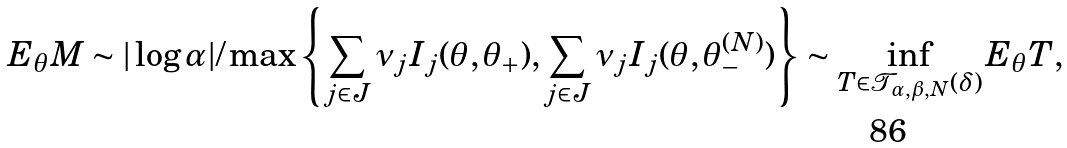<formula> <loc_0><loc_0><loc_500><loc_500>E _ { \theta } M \sim | \log \alpha | / \max \left \{ \sum _ { j \in J } \nu _ { j } I _ { j } ( \theta , \theta _ { + } ) , \sum _ { j \in J } \nu _ { j } I _ { j } ( \theta , \theta _ { - } ^ { ( N ) } ) \right \} \sim \inf _ { T \in \mathcal { T } _ { \alpha , \beta , N } ( \delta ) } E _ { \theta } T ,</formula> 